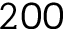<formula> <loc_0><loc_0><loc_500><loc_500>2 0 0</formula> 